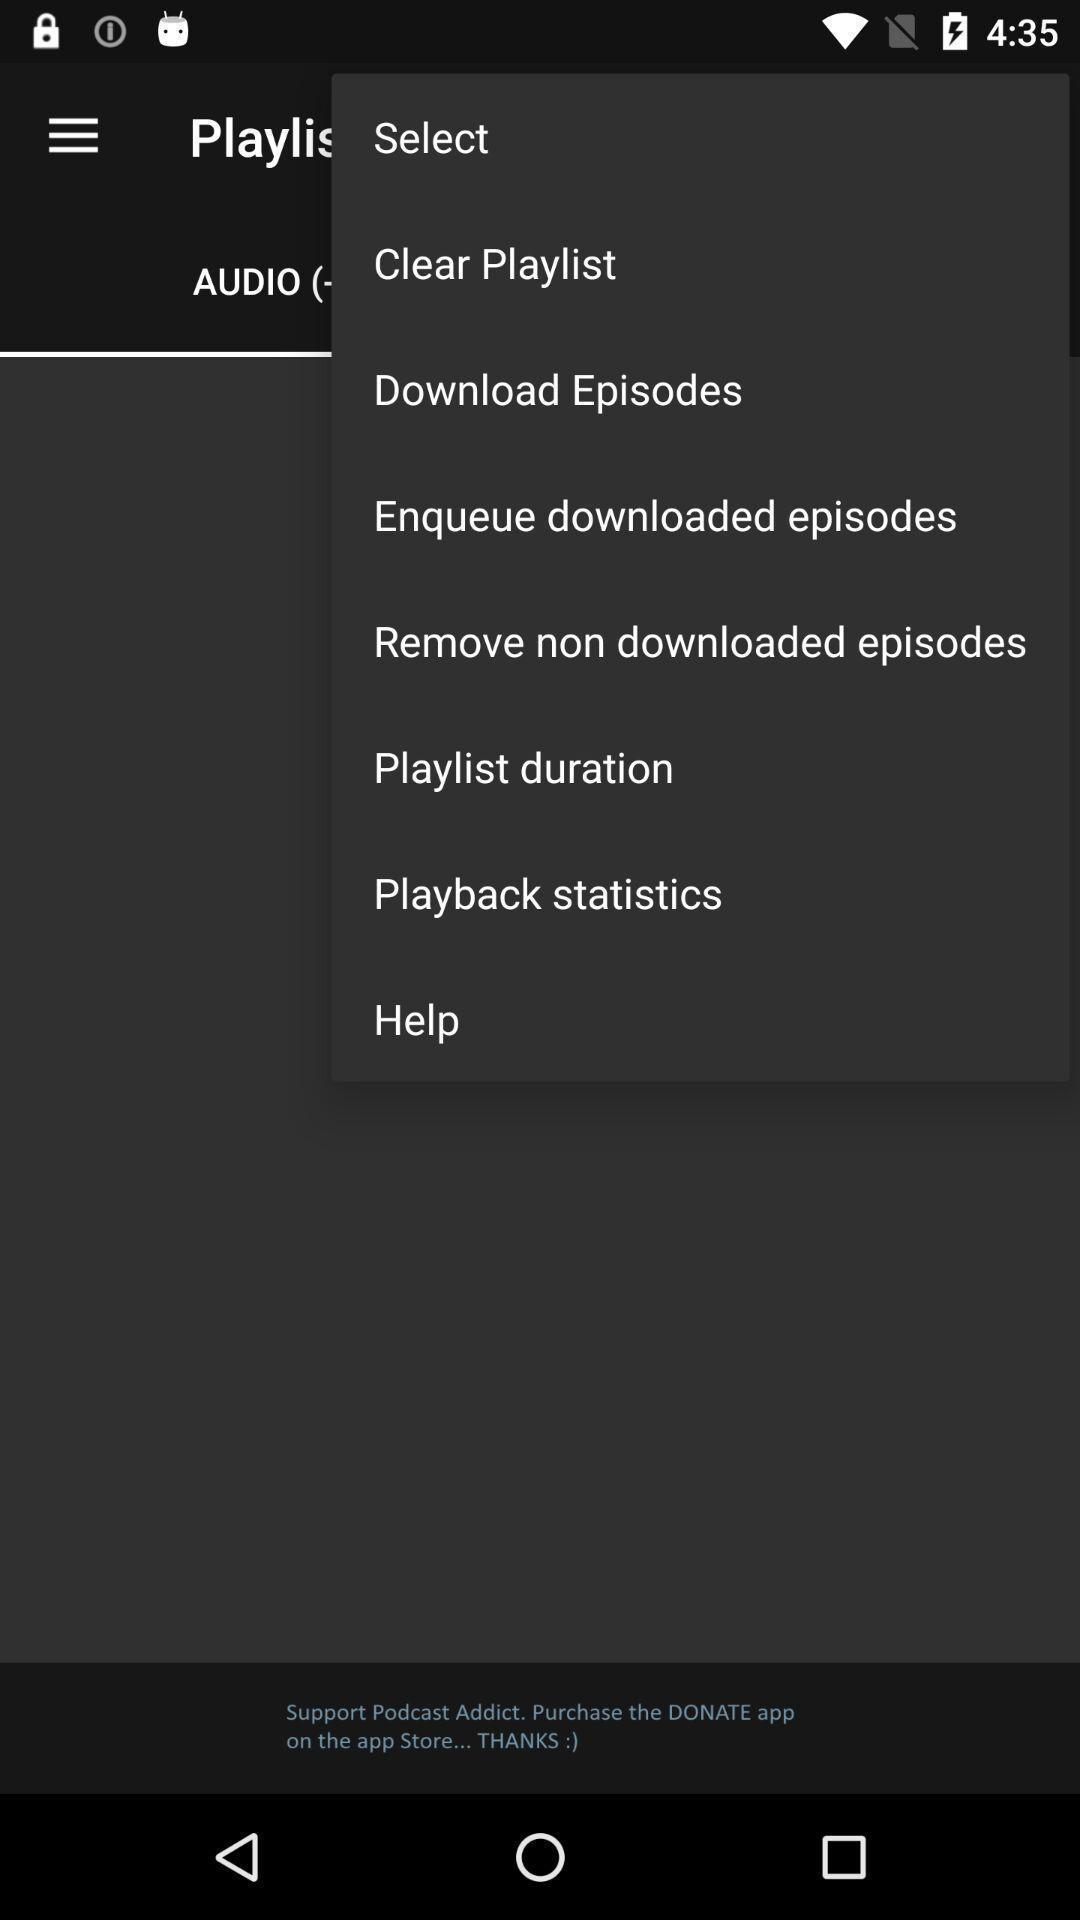Provide a textual representation of this image. Push up notification displayed various options. 